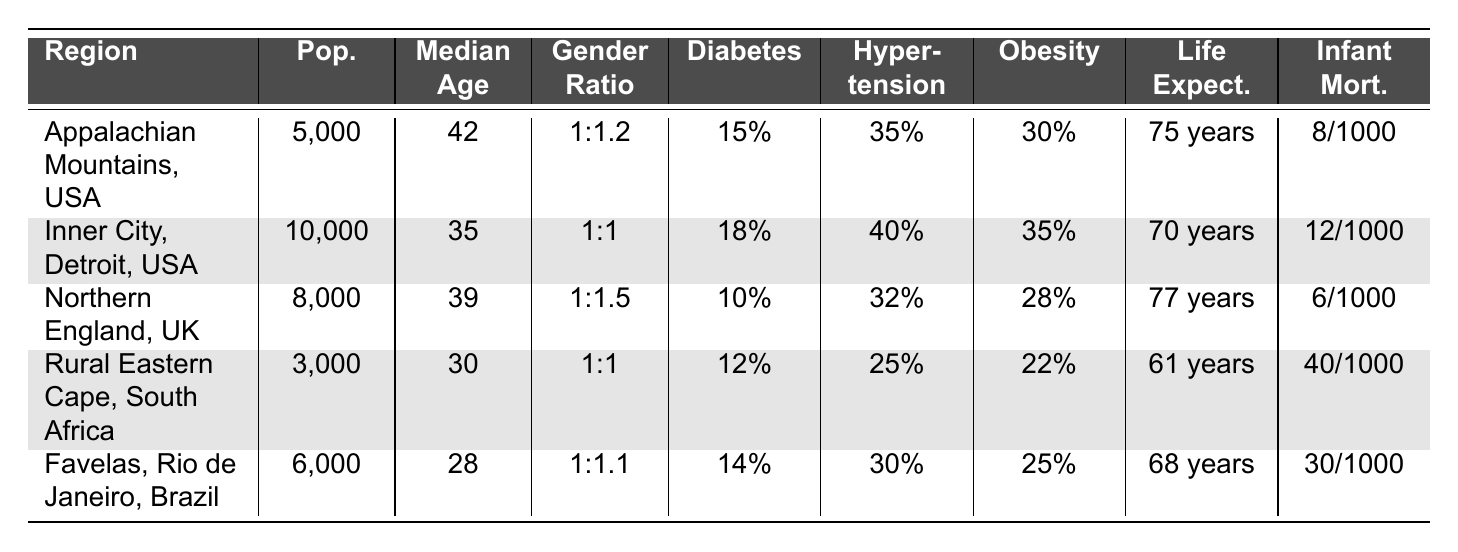What is the median age of patients in the Appalachian Mountains? The table shows that the median age for the Appalachian Mountains is listed directly under the "Median Age" column, which is 42.
Answer: 42 Which region has the highest prevalence of hypertension? By examining the "Hypertension" column, I see that the "Inner City, Detroit, USA" has the highest prevalence at 40%.
Answer: Inner City, Detroit, USA Is the percentage of the population with insurance higher in Favelas, Rio de Janeiro than in Rural Eastern Cape? The percentage with insurance in Favelas is 45%, while in Rural Eastern Cape it's 40%. Since 45% is greater than 40%, this statement is true.
Answer: Yes What are the average life expectancy and infant mortality rates across the five regions? To find the average life expectancy, sum the values (75 + 70 + 77 + 61 + 68) = 351, then divide by 5 to get 70.2 years. For infant mortality, sum the rates (8 + 12 + 6 + 40 + 30) = 96, divide by 5 to get 19.2 per 1000 live births. Therefore, the average life expectancy is 70.2 and the average infant mortality rate is 19.2.
Answer: Life Expectancy: 70.2 years, Infant Mortality Rate: 19.2 per 1000 What is the gender ratio in Northern England? The table directly indicates the gender ratio for Northern England is 1:1.5, meaning there are one male for every 1.5 females.
Answer: 1:1.5 Which region shows the lowest life expectancy? In the "Life Expectancy" column, I can see that "Rural Eastern Cape, South Africa" has the lowest life expectancy at 61 years.
Answer: Rural Eastern Cape, South Africa What percentage of the population in the Appalachian Mountains suffers from obesity? The table indicates that 30% of the population in the Appalachian Mountains suffers from obesity, found directly in the "Obesity" column.
Answer: 30% Calculate the difference in infant mortality rates between Inner City, Detroit and Northern England. The infant mortality rate in Inner City, Detroit is 12 per 1000 live births, and in Northern England it is 6 per 1000 live births. The difference is 12 - 6 = 6 per 1000 live births.
Answer: 6 per 1000 Is life expectancy in the Favelas, Rio de Janeiro higher than that in Rural Eastern Cape? The life expectancy in Favelas is 68 years while in Rural Eastern Cape it's 61 years. Since 68 is greater than 61, this statement is true.
Answer: Yes Which region has a higher diabetes prevalence, Appalachian Mountains or Favelas, Rio de Janeiro? The diabetes prevalence in Appalachian Mountains is 15% and in Favelas is 14%. Hence, Appalachian Mountains has a higher prevalence of diabetes.
Answer: Appalachian Mountains What is the total population across all regions presented in the table? To find the total population, sum the populations of all regions: 5000 + 10000 + 8000 + 3000 + 6000 = 33000.
Answer: 33000 